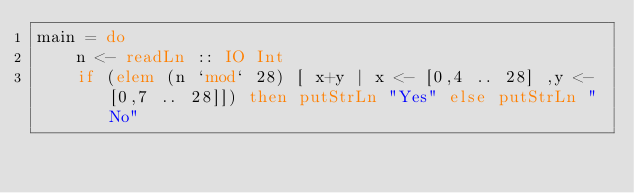<code> <loc_0><loc_0><loc_500><loc_500><_Haskell_>main = do
    n <- readLn :: IO Int
    if (elem (n `mod` 28) [ x+y | x <- [0,4 .. 28] ,y <- [0,7 .. 28]]) then putStrLn "Yes" else putStrLn "No"</code> 